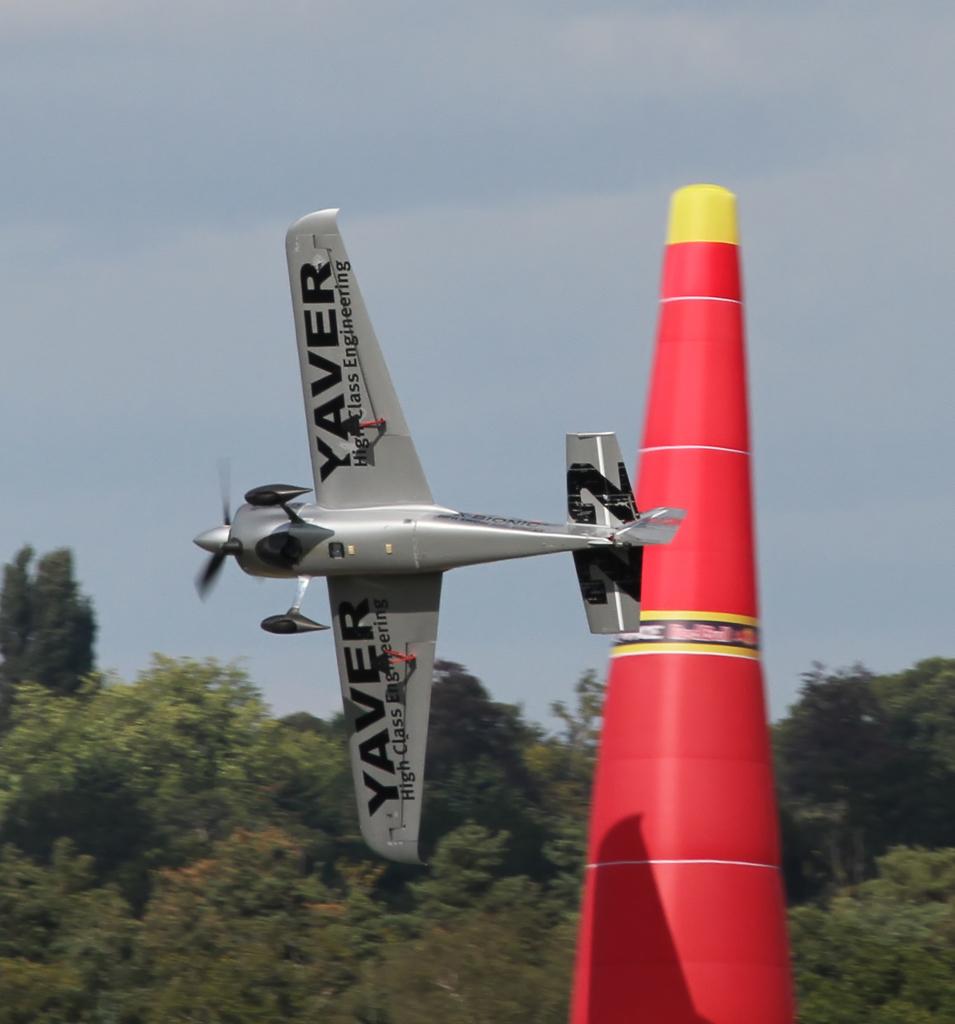What is the tail number on the plane?
Offer a very short reply. 22. What word is on the wings on the plane?
Your answer should be very brief. Yaver. 